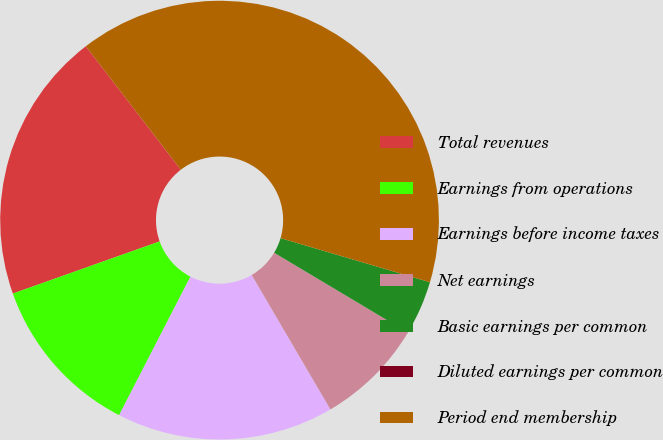Convert chart to OTSL. <chart><loc_0><loc_0><loc_500><loc_500><pie_chart><fcel>Total revenues<fcel>Earnings from operations<fcel>Earnings before income taxes<fcel>Net earnings<fcel>Basic earnings per common<fcel>Diluted earnings per common<fcel>Period end membership<nl><fcel>20.0%<fcel>12.0%<fcel>16.0%<fcel>8.0%<fcel>4.0%<fcel>0.0%<fcel>40.0%<nl></chart> 